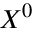<formula> <loc_0><loc_0><loc_500><loc_500>X ^ { 0 }</formula> 